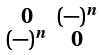<formula> <loc_0><loc_0><loc_500><loc_500>\begin{smallmatrix} 0 & ( - ) ^ { n } \\ ( - ) ^ { n } & 0 \end{smallmatrix}</formula> 